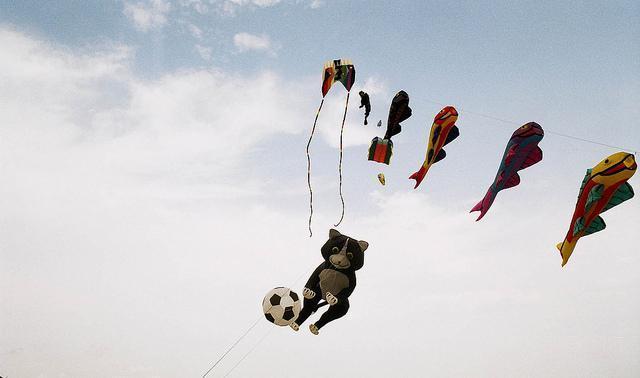How many kites are there?
Give a very brief answer. 3. How many sheep are pictured?
Give a very brief answer. 0. 